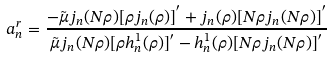Convert formula to latex. <formula><loc_0><loc_0><loc_500><loc_500>a _ { n } ^ { r } = \frac { - \tilde { \mu } j _ { n } ( N \rho ) [ \rho j _ { n } ( \rho ) ] ^ { ^ { \prime } } + j _ { n } ( \rho ) [ N \rho j _ { n } ( N \rho ) ] ^ { ^ { \prime } } } { \tilde { \mu } j _ { n } ( N \rho ) [ \rho h _ { n } ^ { 1 } ( \rho ) ] ^ { ^ { \prime } } - h _ { n } ^ { 1 } ( \rho ) [ N \rho j _ { n } ( N \rho ) ] ^ { ^ { \prime } } }</formula> 